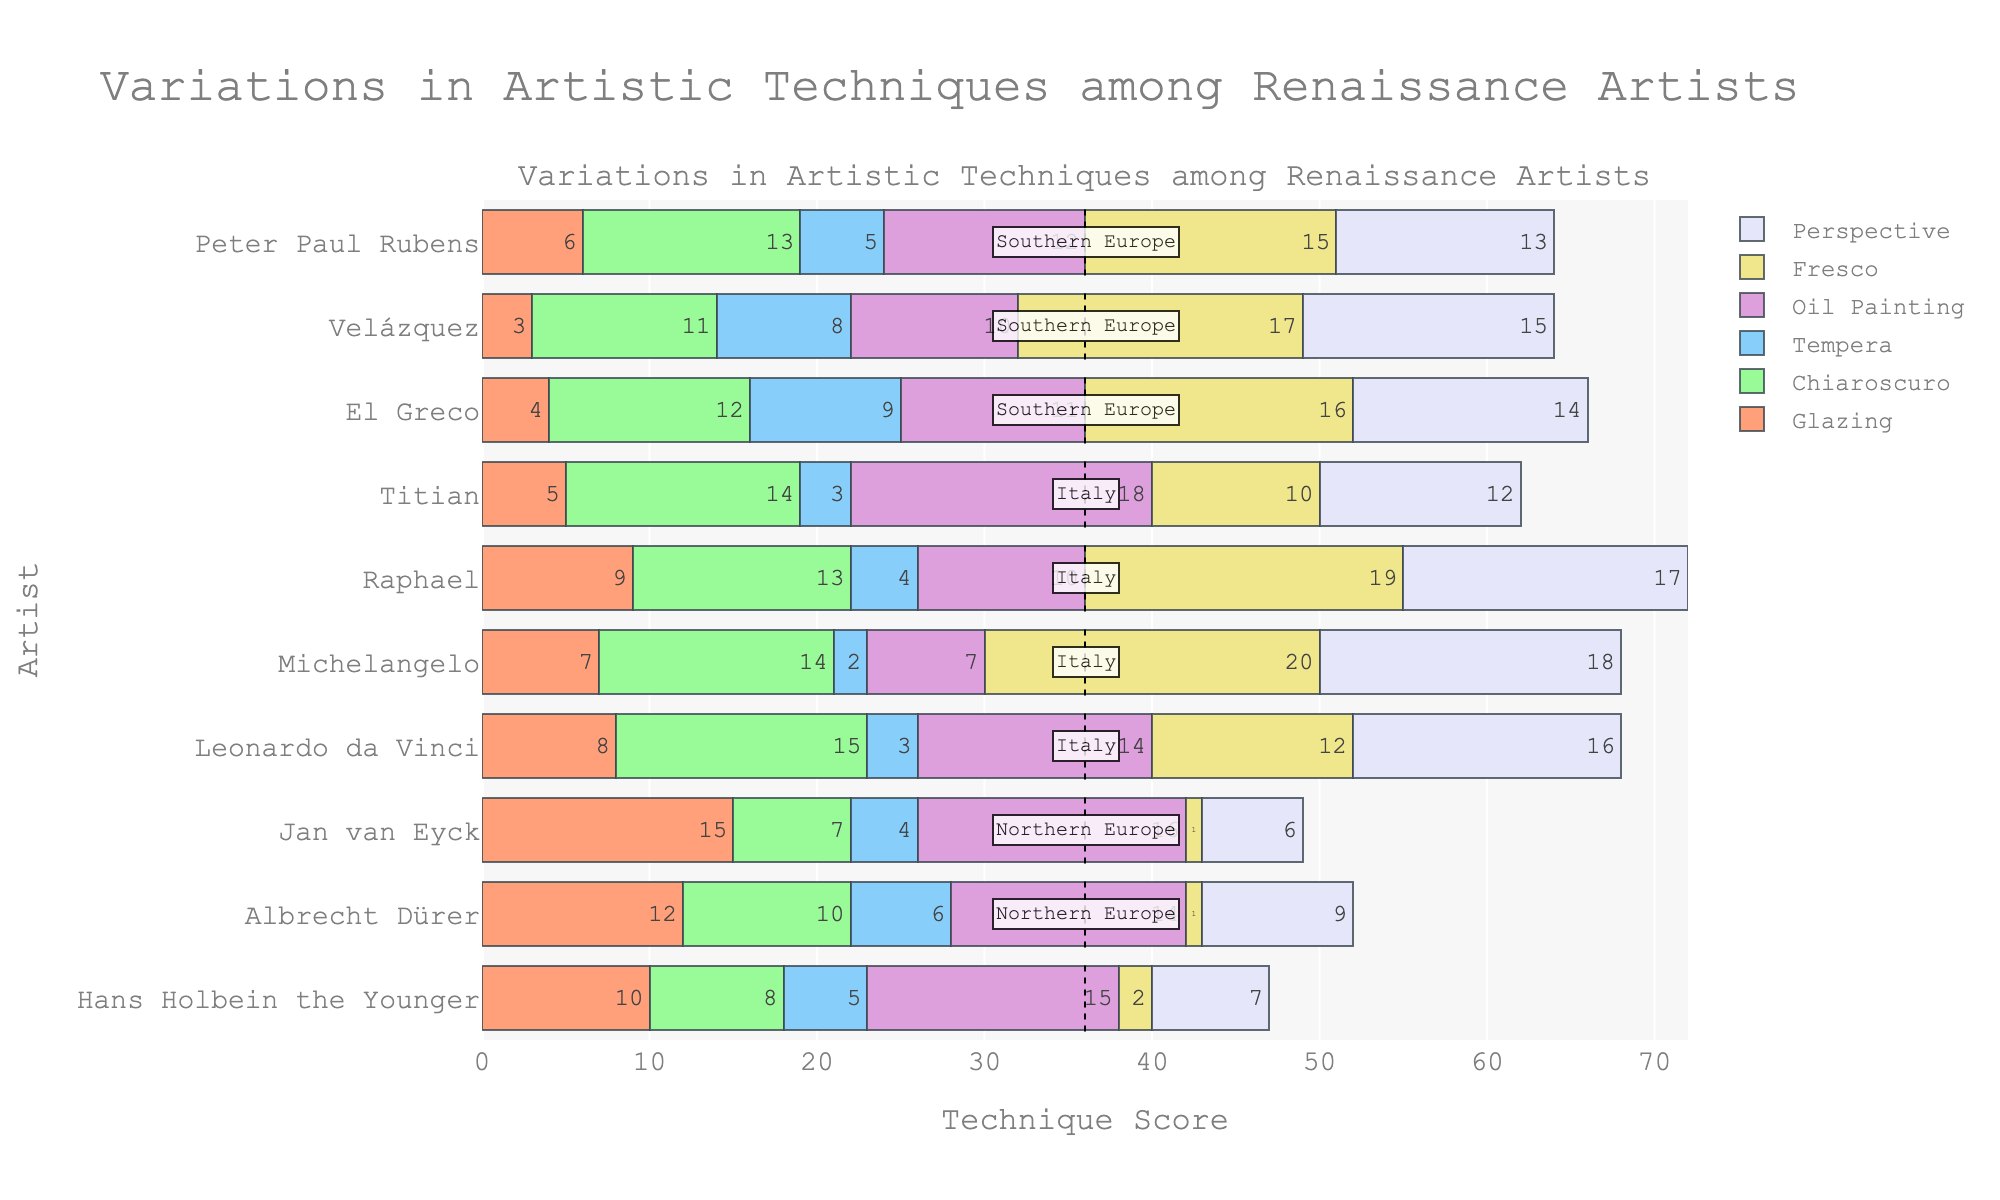What's the sum of the technique scores for Hans Holbein the Younger? Sum up all values for Hans Holbein the Younger: 10 (Glazing) + 8 (Chiaroscuro) + 5 (Tempera) + 15 (Oil Painting) + 2 (Fresco) + 7 (Perspective) = 47
Answer: 47 Which artist has the highest score in Fresco? By checking the topmost value in the Fresco category, Michelangelo has the highest score with 20 in Fresco.
Answer: Michelangelo Among Northern European artists, who has the greatest score in perspective? By comparing Perspective scores among Northern European artists: Hans Holbein the Younger (7), Albrecht Dürer (9), Jan van Eyck (6). Albrecht Dürer has the highest score.
Answer: Albrecht Dürer Which artistic technique has the highest collective score among Italian artists? Sum the scores for each technique among Leonardo da Vinci, Michelangelo, Raphael, and Titian. Glazing (8 + 7 + 9 + 5 = 29), Chiaroscuro (15 + 14 + 13 + 14 = 56), Tempera (3 + 2 + 4 + 3 = 12), Oil Painting (14 + 7 + 10 + 18 = 49), Fresco (12 + 20 + 19 + 10 = 61), Perspective (16 + 18 + 17 + 12 = 63). Perspective has the highest score: 63.
Answer: Perspective For El Greco, what is the difference between his Chiaroscuro score and his Oil Painting score? El Greco's Chiaroscuro score is 12 and Oil Painting score is 11. Thus, the difference is 12 - 11 = 1.
Answer: 1 How many artists have an Oil Painting score greater than 12? Check the oil painting scores: Hans Holbein the Younger (15), Albrecht Dürer (14), Jan van Eyck (16), Leonardo da Vinci (14), Michelangelo (7), Raphael (10), Titian (18), El Greco (11), Velázquez (10), Peter Paul Rubens (12). Four artists (Hans Holbein the Younger, Albrecht Dürer, Jan van Eyck, Leonardo da Vinci, Titian) have scores greater than 12.
Answer: 5 Which Southern European artist has the lowest score in Glazing? Compare Glazing scores among El Greco (4), Velázquez (3), Peter Paul Rubens (6). Velázquez has the lowest score in Glazing with a score of 3.
Answer: Velázquez What is the average Chiaroscuro score across all artists? Sum up all Chiaroscuro values: 8 (Hans Holbein the Younger) + 10 (Albrecht Dürer) + 7 (Jan van Eyck) + 15 (Leonardo da Vinci) + 14 (Michelangelo) + 13 (Raphael) + 14 (Titian) + 12 (El Greco) + 11 (Velázquez) + 13 (Peter Paul Rubens) = 117. Divide by the number of artists, which is 10, so 117 / 10 = 11.7
Answer: 11.7 Which artist has the smallest total variation in their technique scores? Calculate the total variation (range) for each artist's scores and identify the smallest. Difference between max and min scores for each artist: Hans Holbein the Younger (15-2=13), Albrecht Dürer (14-1=13), Jan van Eyck (16-1=15), Leonardo da Vinci (16-3=13), Michelangelo (20-2=18), Raphael (19-4=15), Titian (18-3=15), El Greco (16-4=12), Velázquez (17-3=14), Peter Paul Rubens (15-5=10). Peter Paul Rubens has the smallest variation (15-5=10).
Answer: Peter Paul Rubens 